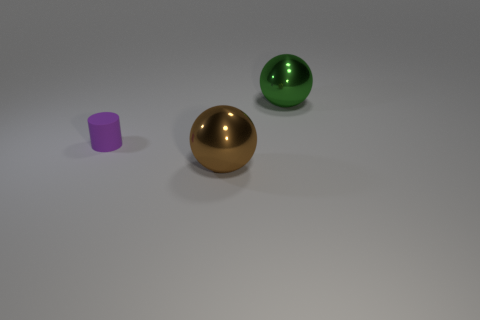Do the large object in front of the matte cylinder and the tiny matte thing behind the brown sphere have the same color?
Your answer should be very brief. No. How many big objects are behind the tiny cylinder?
Offer a terse response. 1. Is there a large brown shiny sphere that is on the right side of the ball that is in front of the big ball that is behind the tiny matte cylinder?
Make the answer very short. No. How many green rubber things are the same size as the green metallic sphere?
Offer a very short reply. 0. The big sphere that is in front of the large object behind the rubber thing is made of what material?
Ensure brevity in your answer.  Metal. There is a metal thing on the left side of the large ball that is behind the cylinder that is on the left side of the large green metallic sphere; what is its shape?
Your answer should be compact. Sphere. Is the shape of the large thing in front of the small thing the same as the metal object behind the tiny rubber cylinder?
Provide a succinct answer. Yes. What number of other objects are there of the same material as the cylinder?
Ensure brevity in your answer.  0. There is a large brown object that is made of the same material as the large green sphere; what shape is it?
Keep it short and to the point. Sphere. Is the purple cylinder the same size as the brown ball?
Your response must be concise. No. 